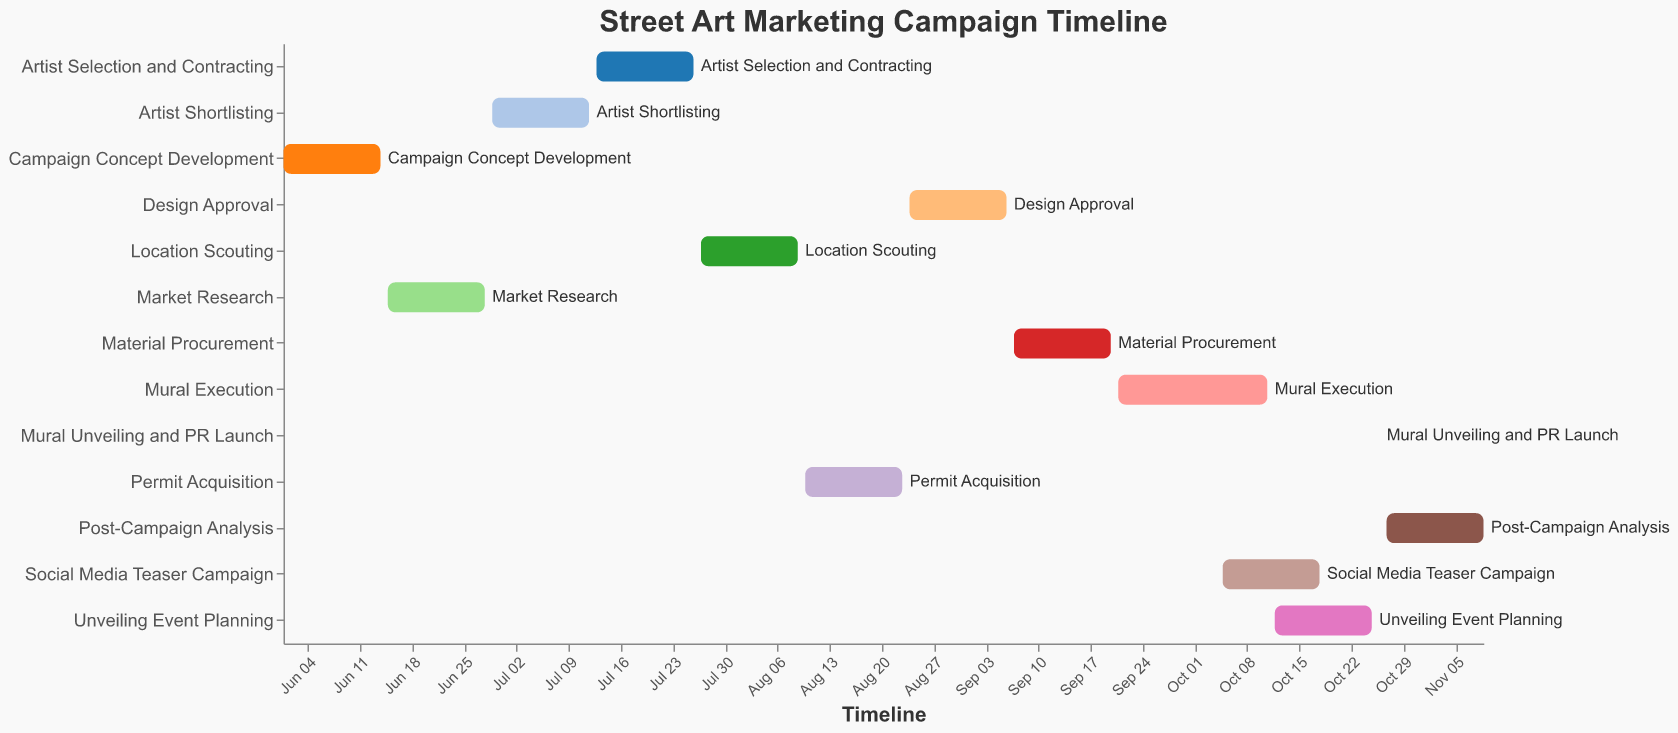When does the Market Research phase start and end? The Gantt Chart shows the start and end dates of each task. To find the Market Research phase, look at the corresponding bars on the chart.
Answer: Starts on June 15, 2023, and ends on June 28, 2023 Which phase takes the longest time? The Gantt Chart provides a visual representation of the duration of each phase using the length of the bars. The phase with the longest bar indicates the longest duration.
Answer: Post-Campaign Analysis What is the duration of the Artist Selection and Contracting phase? Determine the start and end dates for the Artist Selection and Contracting phase from the chart. The duration is calculated as the difference between these dates.
Answer: 14 days How does the timeline of Permit Acquisition compare to that of Location Scouting? Compare the start and end dates of Location Scouting and Permit Acquisition by examining the corresponding bars in the Gantt Chart. Permit Acquisition starts right after Location Scouting ends and also lasts two weeks.
Answer: Permit Acquisition starts after Location Scouting and both last two weeks Which phases overlap with the Mural Execution phase? Identify the start and end dates of the Mural Execution phase from the chart, and then compare these dates with other phases to see which ones overlap.
Answer: Social Media Teaser Campaign and Unveiling Event Planning How many phases are completed before the Material Procurement phase starts? List the phases in the order they appear on the Gantt Chart and count how many are completed before the start date of Material Procurement.
Answer: 7 phases What is the total duration of the street art marketing campaign from start to finish? Identify the start date of the first phase and the end date of the last phase from the Gantt Chart. Calculate the total duration as the difference between these dates.
Answer: June 1, 2023, to November 9, 2023 Which phase begins immediately after the Design Approval phase? Check the end date of the Design Approval phase and the start date of the phases following it to see which one begins immediately after.
Answer: Material Procurement During which dates does the Unveiling Event Planning phase take place? Locate the bar representing the Unveiling Event Planning phase on the Gantt Chart and note its start and end dates.
Answer: October 12, 2023, to October 25, 2023 What is the shortest phase in the campaign and how long does it last? Examine the lengths of all the bars in the Gantt Chart to identify the shortest one, then note the duration from its start and end dates.
Answer: Mural Unveiling and PR Launch, which lasts 1 day 